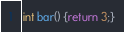Convert code to text. <code><loc_0><loc_0><loc_500><loc_500><_C_>int bar() {return 3;}
</code> 